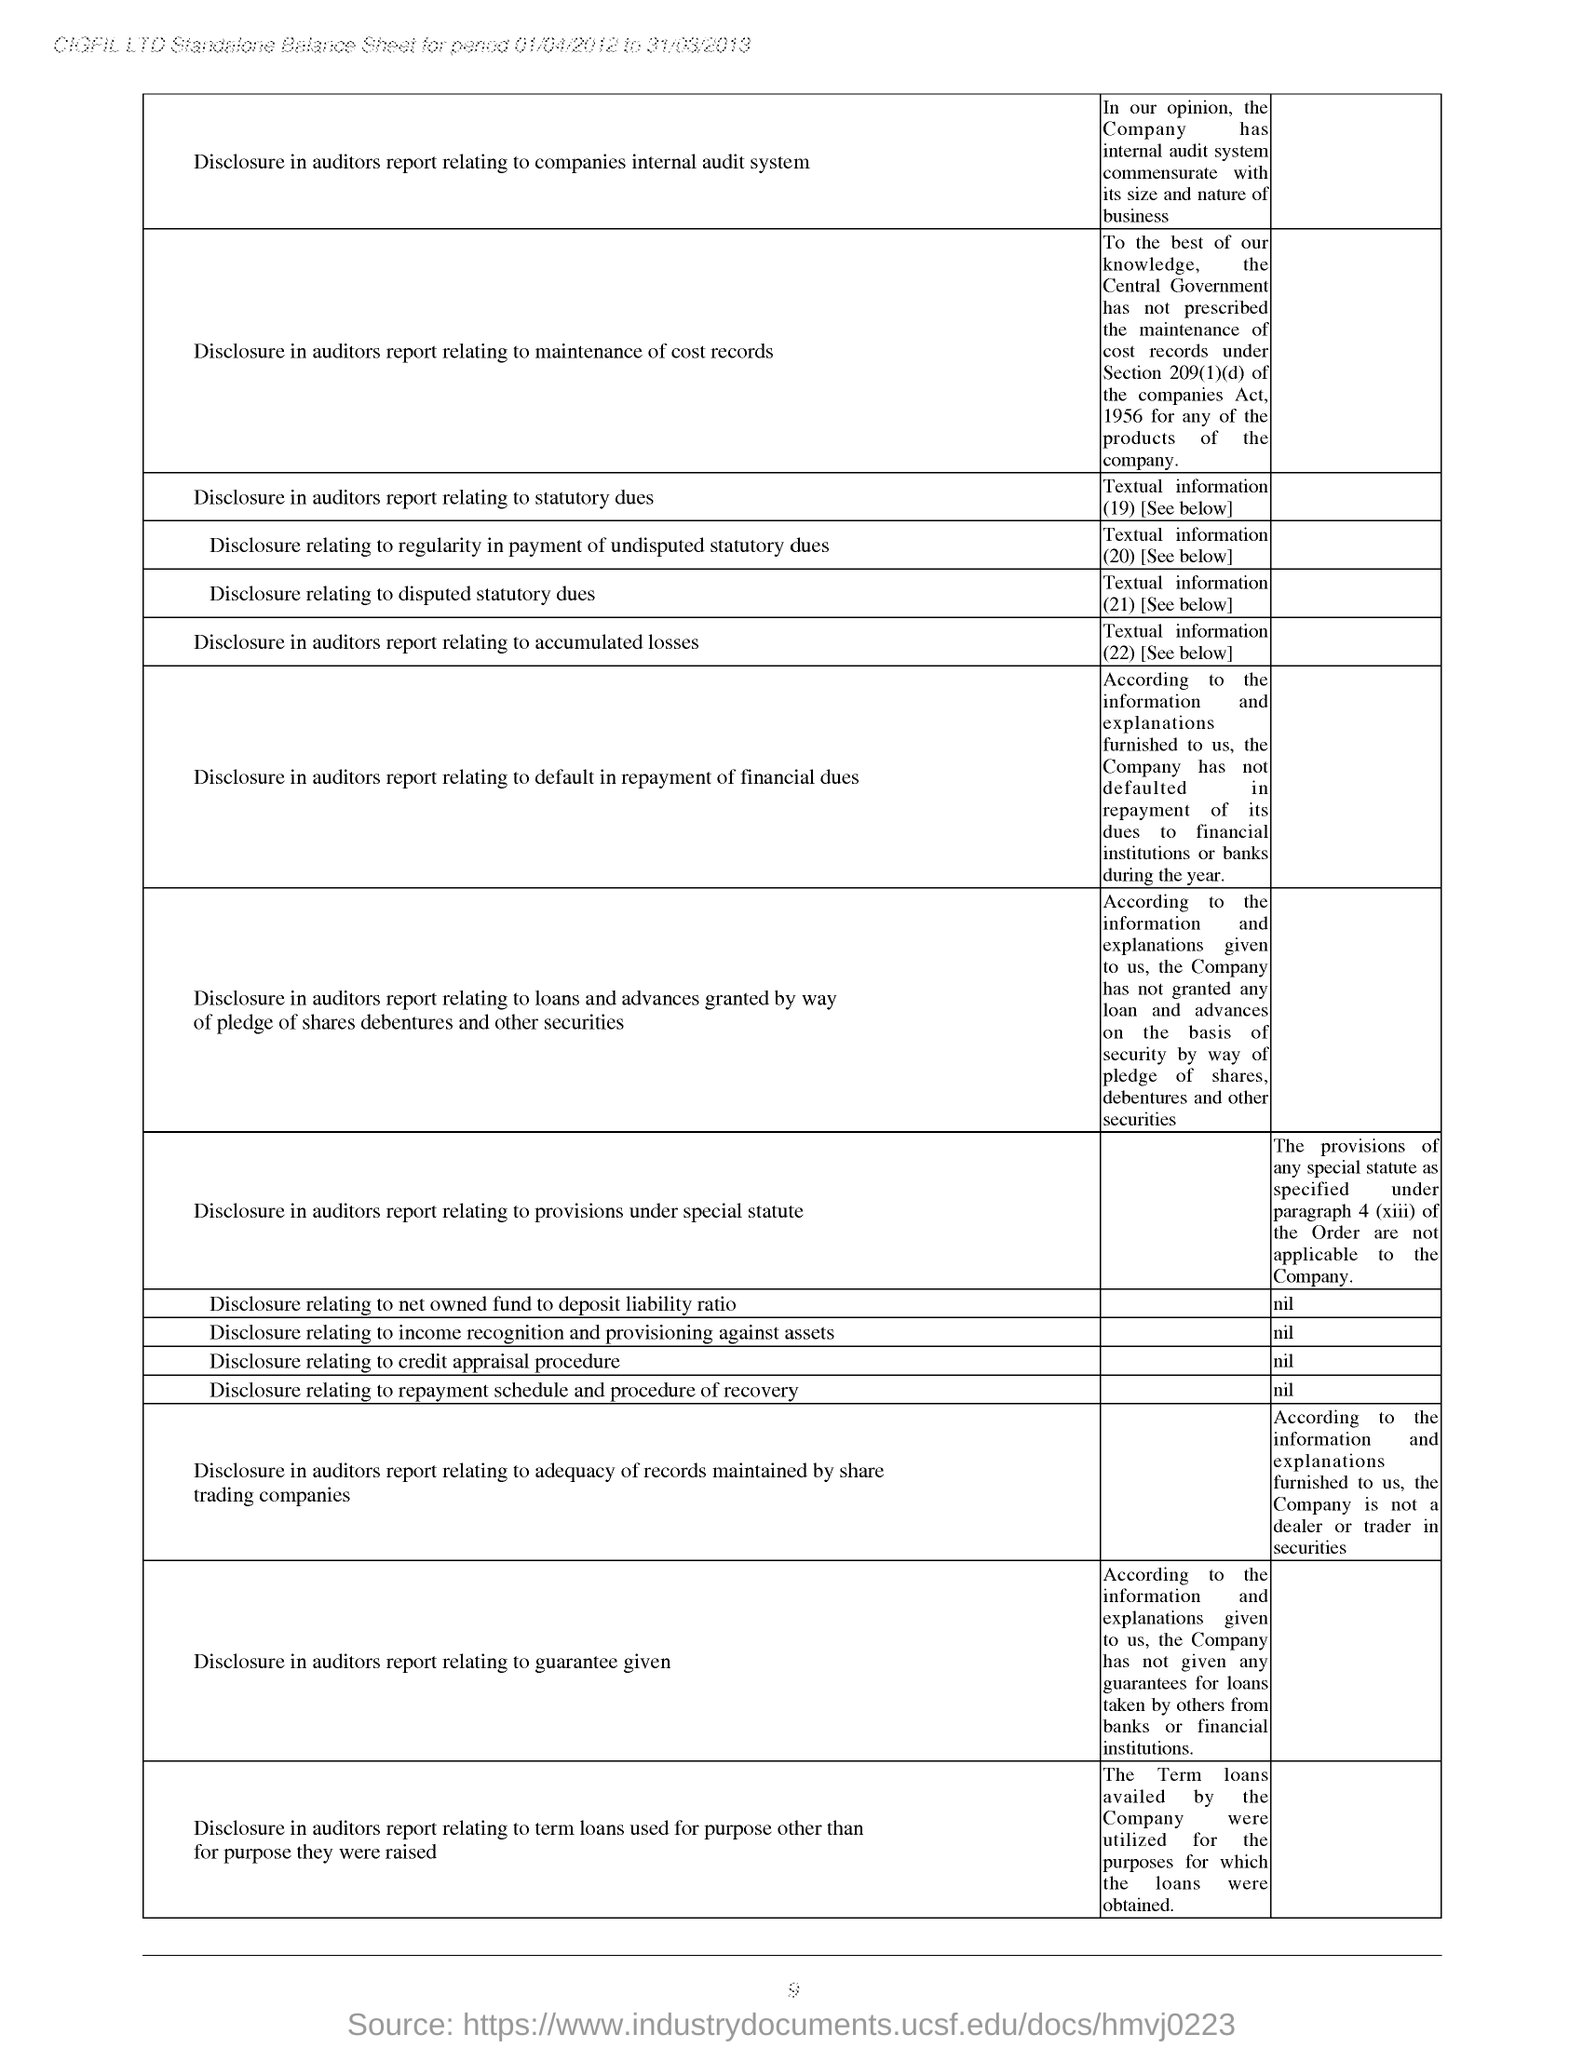What is the company name mentioned at the top of the page?
Provide a short and direct response. CIGFIL LTD. For which period duration is standalone Balance sheet made?
Your response must be concise. 01/04/2012 to 31/03/2013. What is the first Disclosure mentioned in the Balance sheet?
Provide a short and direct response. Disclosure in auditors report relating to companies internal audit system. What is the value entered for "Disclosure relating to net owned fund to deposit liability ratio"?
Your answer should be very brief. Nil. 